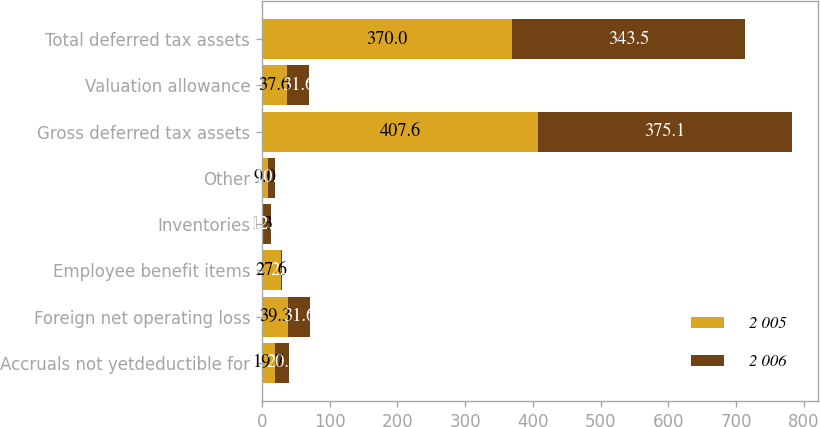Convert chart to OTSL. <chart><loc_0><loc_0><loc_500><loc_500><stacked_bar_chart><ecel><fcel>Accruals not yetdeductible for<fcel>Foreign net operating loss<fcel>Employee benefit items<fcel>Inventories<fcel>Other<fcel>Gross deferred tax assets<fcel>Valuation allowance<fcel>Total deferred tax assets<nl><fcel>2 005<fcel>19.7<fcel>39.3<fcel>27.6<fcel>1.3<fcel>9<fcel>407.6<fcel>37.6<fcel>370<nl><fcel>2 006<fcel>20.8<fcel>31.6<fcel>2.5<fcel>12.1<fcel>10.5<fcel>375.1<fcel>31.6<fcel>343.5<nl></chart> 